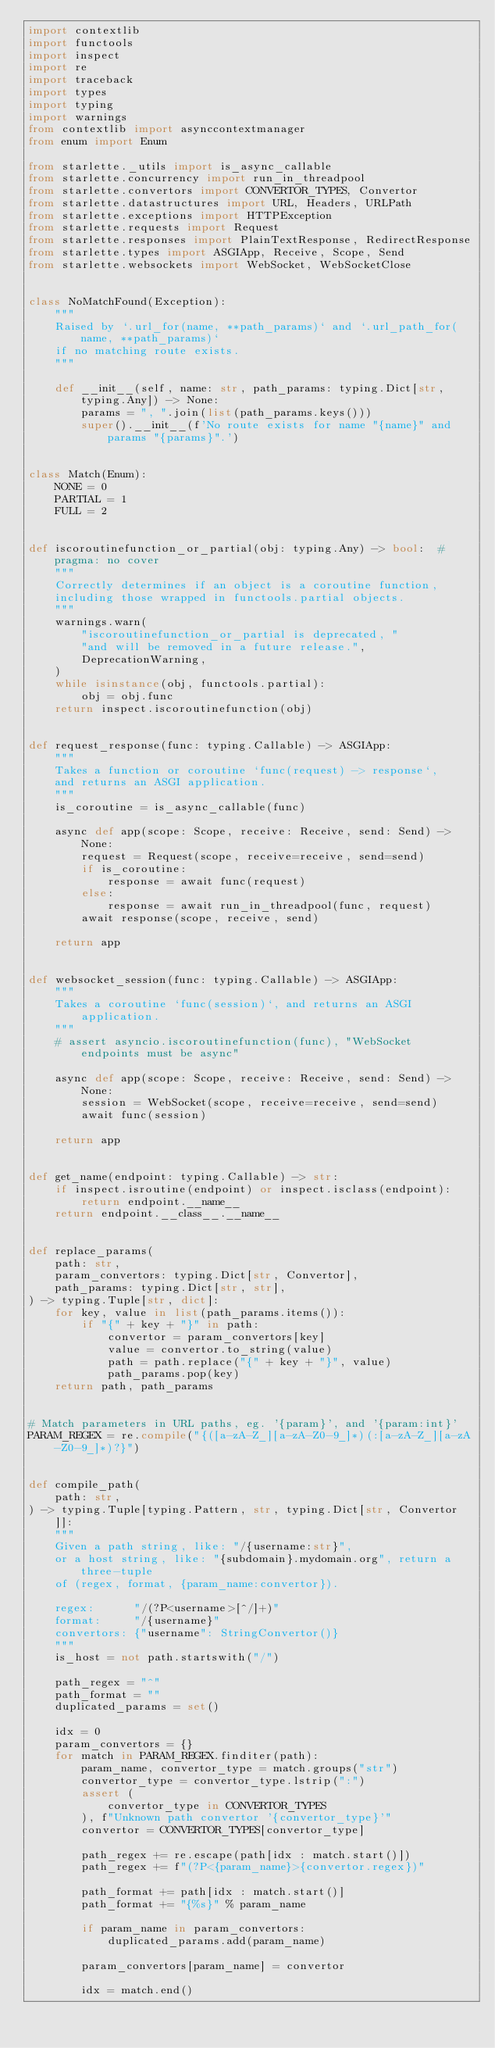<code> <loc_0><loc_0><loc_500><loc_500><_Python_>import contextlib
import functools
import inspect
import re
import traceback
import types
import typing
import warnings
from contextlib import asynccontextmanager
from enum import Enum

from starlette._utils import is_async_callable
from starlette.concurrency import run_in_threadpool
from starlette.convertors import CONVERTOR_TYPES, Convertor
from starlette.datastructures import URL, Headers, URLPath
from starlette.exceptions import HTTPException
from starlette.requests import Request
from starlette.responses import PlainTextResponse, RedirectResponse
from starlette.types import ASGIApp, Receive, Scope, Send
from starlette.websockets import WebSocket, WebSocketClose


class NoMatchFound(Exception):
    """
    Raised by `.url_for(name, **path_params)` and `.url_path_for(name, **path_params)`
    if no matching route exists.
    """

    def __init__(self, name: str, path_params: typing.Dict[str, typing.Any]) -> None:
        params = ", ".join(list(path_params.keys()))
        super().__init__(f'No route exists for name "{name}" and params "{params}".')


class Match(Enum):
    NONE = 0
    PARTIAL = 1
    FULL = 2


def iscoroutinefunction_or_partial(obj: typing.Any) -> bool:  # pragma: no cover
    """
    Correctly determines if an object is a coroutine function,
    including those wrapped in functools.partial objects.
    """
    warnings.warn(
        "iscoroutinefunction_or_partial is deprecated, "
        "and will be removed in a future release.",
        DeprecationWarning,
    )
    while isinstance(obj, functools.partial):
        obj = obj.func
    return inspect.iscoroutinefunction(obj)


def request_response(func: typing.Callable) -> ASGIApp:
    """
    Takes a function or coroutine `func(request) -> response`,
    and returns an ASGI application.
    """
    is_coroutine = is_async_callable(func)

    async def app(scope: Scope, receive: Receive, send: Send) -> None:
        request = Request(scope, receive=receive, send=send)
        if is_coroutine:
            response = await func(request)
        else:
            response = await run_in_threadpool(func, request)
        await response(scope, receive, send)

    return app


def websocket_session(func: typing.Callable) -> ASGIApp:
    """
    Takes a coroutine `func(session)`, and returns an ASGI application.
    """
    # assert asyncio.iscoroutinefunction(func), "WebSocket endpoints must be async"

    async def app(scope: Scope, receive: Receive, send: Send) -> None:
        session = WebSocket(scope, receive=receive, send=send)
        await func(session)

    return app


def get_name(endpoint: typing.Callable) -> str:
    if inspect.isroutine(endpoint) or inspect.isclass(endpoint):
        return endpoint.__name__
    return endpoint.__class__.__name__


def replace_params(
    path: str,
    param_convertors: typing.Dict[str, Convertor],
    path_params: typing.Dict[str, str],
) -> typing.Tuple[str, dict]:
    for key, value in list(path_params.items()):
        if "{" + key + "}" in path:
            convertor = param_convertors[key]
            value = convertor.to_string(value)
            path = path.replace("{" + key + "}", value)
            path_params.pop(key)
    return path, path_params


# Match parameters in URL paths, eg. '{param}', and '{param:int}'
PARAM_REGEX = re.compile("{([a-zA-Z_][a-zA-Z0-9_]*)(:[a-zA-Z_][a-zA-Z0-9_]*)?}")


def compile_path(
    path: str,
) -> typing.Tuple[typing.Pattern, str, typing.Dict[str, Convertor]]:
    """
    Given a path string, like: "/{username:str}",
    or a host string, like: "{subdomain}.mydomain.org", return a three-tuple
    of (regex, format, {param_name:convertor}).

    regex:      "/(?P<username>[^/]+)"
    format:     "/{username}"
    convertors: {"username": StringConvertor()}
    """
    is_host = not path.startswith("/")

    path_regex = "^"
    path_format = ""
    duplicated_params = set()

    idx = 0
    param_convertors = {}
    for match in PARAM_REGEX.finditer(path):
        param_name, convertor_type = match.groups("str")
        convertor_type = convertor_type.lstrip(":")
        assert (
            convertor_type in CONVERTOR_TYPES
        ), f"Unknown path convertor '{convertor_type}'"
        convertor = CONVERTOR_TYPES[convertor_type]

        path_regex += re.escape(path[idx : match.start()])
        path_regex += f"(?P<{param_name}>{convertor.regex})"

        path_format += path[idx : match.start()]
        path_format += "{%s}" % param_name

        if param_name in param_convertors:
            duplicated_params.add(param_name)

        param_convertors[param_name] = convertor

        idx = match.end()
</code> 